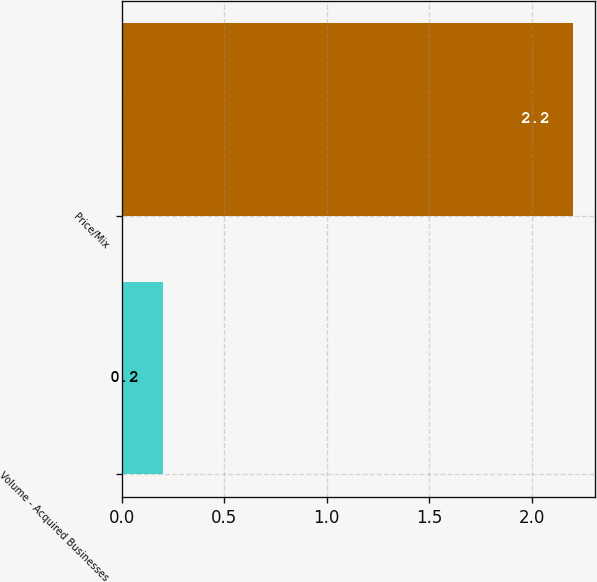<chart> <loc_0><loc_0><loc_500><loc_500><bar_chart><fcel>Volume - Acquired Businesses<fcel>Price/Mix<nl><fcel>0.2<fcel>2.2<nl></chart> 